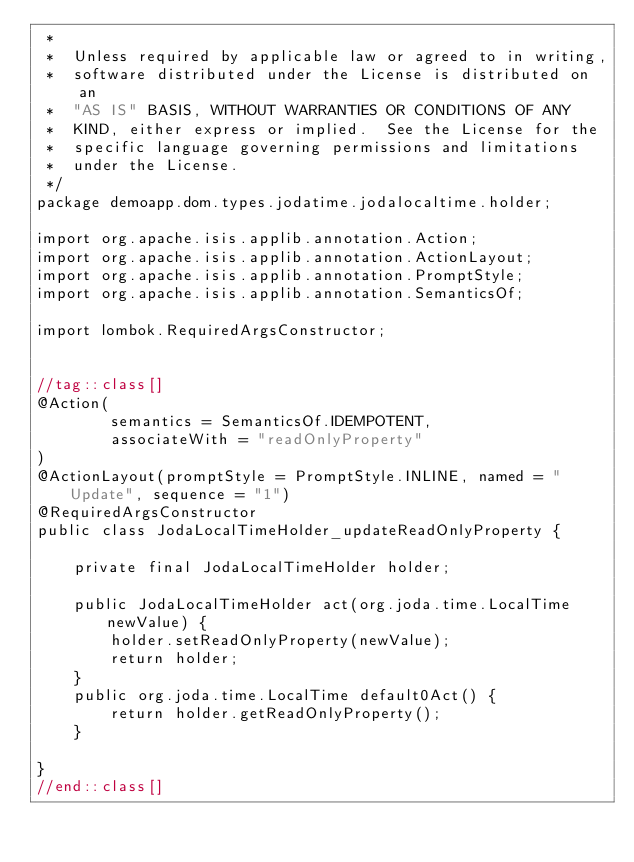<code> <loc_0><loc_0><loc_500><loc_500><_Java_> *
 *  Unless required by applicable law or agreed to in writing,
 *  software distributed under the License is distributed on an
 *  "AS IS" BASIS, WITHOUT WARRANTIES OR CONDITIONS OF ANY
 *  KIND, either express or implied.  See the License for the
 *  specific language governing permissions and limitations
 *  under the License.
 */
package demoapp.dom.types.jodatime.jodalocaltime.holder;

import org.apache.isis.applib.annotation.Action;
import org.apache.isis.applib.annotation.ActionLayout;
import org.apache.isis.applib.annotation.PromptStyle;
import org.apache.isis.applib.annotation.SemanticsOf;

import lombok.RequiredArgsConstructor;


//tag::class[]
@Action(
        semantics = SemanticsOf.IDEMPOTENT,
        associateWith = "readOnlyProperty"
)
@ActionLayout(promptStyle = PromptStyle.INLINE, named = "Update", sequence = "1")
@RequiredArgsConstructor
public class JodaLocalTimeHolder_updateReadOnlyProperty {

    private final JodaLocalTimeHolder holder;

    public JodaLocalTimeHolder act(org.joda.time.LocalTime newValue) {
        holder.setReadOnlyProperty(newValue);
        return holder;
    }
    public org.joda.time.LocalTime default0Act() {
        return holder.getReadOnlyProperty();
    }

}
//end::class[]
</code> 